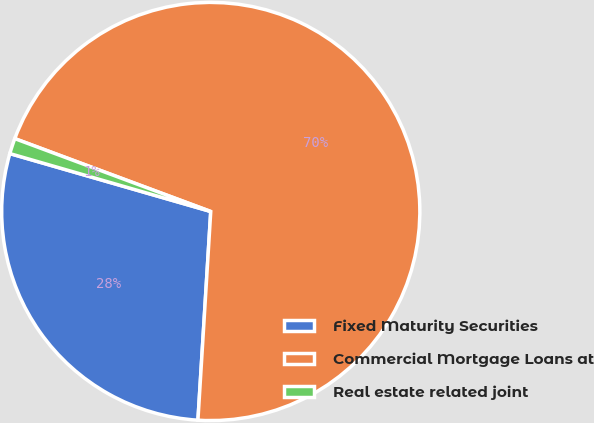<chart> <loc_0><loc_0><loc_500><loc_500><pie_chart><fcel>Fixed Maturity Securities<fcel>Commercial Mortgage Loans at<fcel>Real estate related joint<nl><fcel>28.49%<fcel>70.31%<fcel>1.2%<nl></chart> 